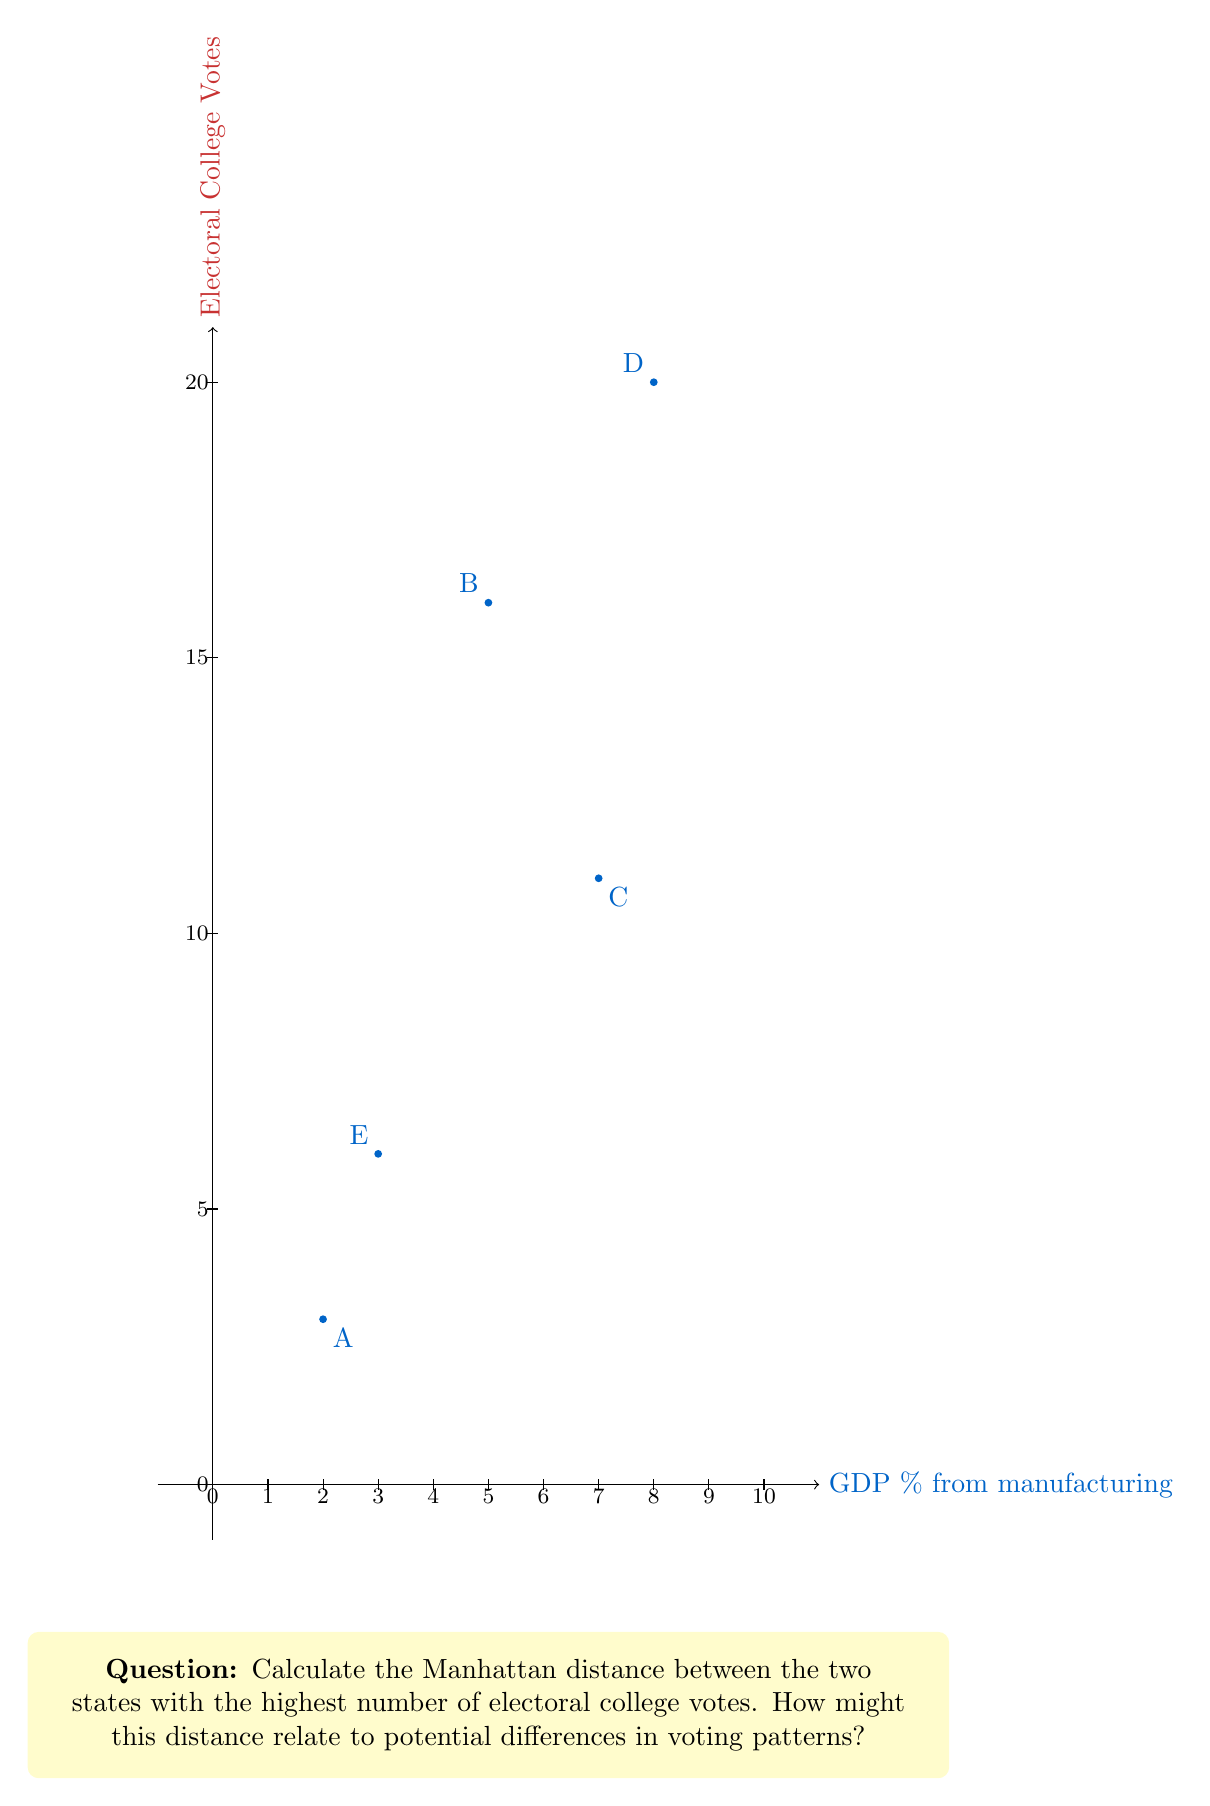Show me your answer to this math problem. To solve this problem, we need to follow these steps:

1. Identify the two states with the highest number of electoral college votes:
   Looking at the y-axis (electoral college votes), we can see that states D and B have the highest values.
   State D: (8, 20)
   State B: (5, 16)

2. Calculate the Manhattan distance:
   The Manhattan distance is the sum of the absolute differences of the x and y coordinates.
   
   Manhattan distance = $|x_2 - x_1| + |y_2 - y_1|$
   
   Where $(x_1, y_1)$ is the coordinate of one point and $(x_2, y_2)$ is the coordinate of the other point.

3. Plug in the values:
   $|x_2 - x_1| = |8 - 5| = |3| = 3$
   $|y_2 - y_1| = |20 - 16| = |4| = 4$

4. Sum the absolute differences:
   Manhattan distance = $3 + 4 = 7$

Interpretation:
The Manhattan distance of 7 indicates a significant difference between these two high-electoral-vote states in terms of both their manufacturing GDP percentage and their electoral college votes. This distance suggests that:

1. There's a 3% difference in the GDP from manufacturing between these states.
2. There's a 4-vote difference in their electoral college allocation.

From a conservative political science perspective, this distance could imply:

1. Different economic structures may lead to different voting patterns, with the state having a higher manufacturing GDP possibly leaning more towards policies that support traditional industries.
2. The difference in electoral votes suggests varying population sizes or historical electoral importance, which could influence campaign strategies and policy focuses for each state.
3. The combination of these factors might indicate a potential divide in interests and priorities between industrial-focused states and those with more diverse economic bases, possibly leading to different voting behaviors in presidential elections.
Answer: 7 